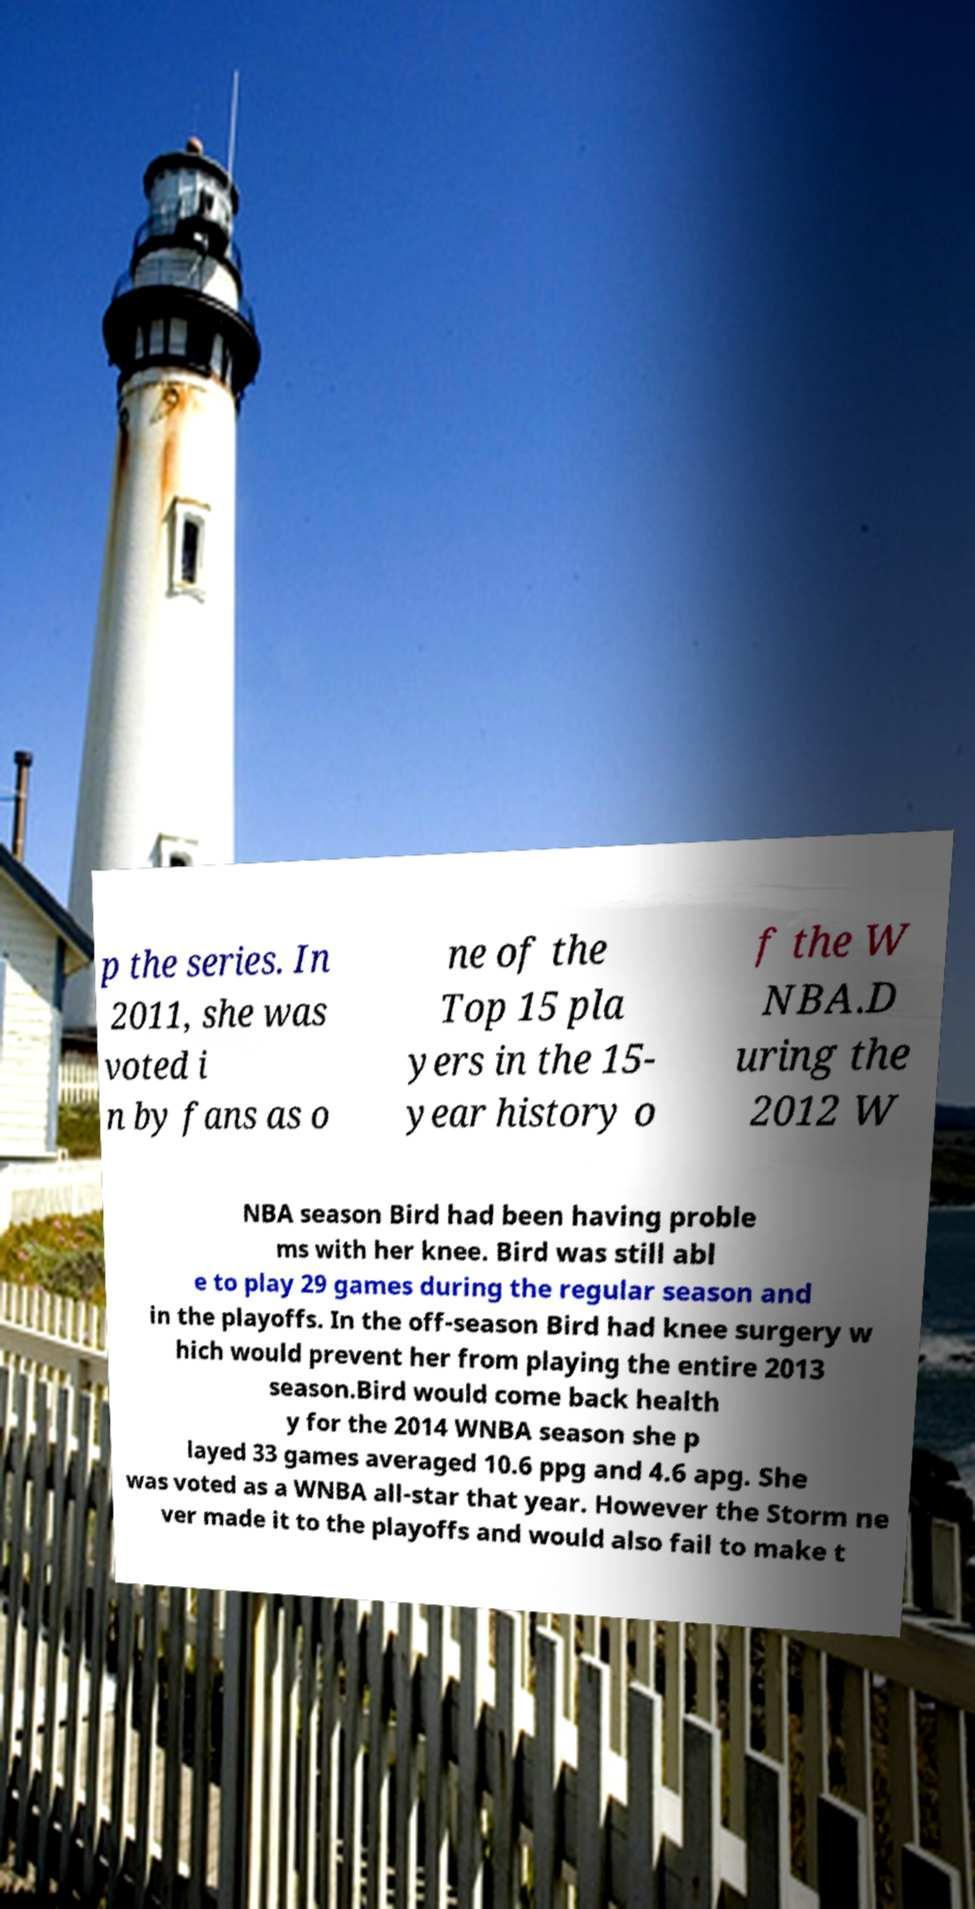There's text embedded in this image that I need extracted. Can you transcribe it verbatim? p the series. In 2011, she was voted i n by fans as o ne of the Top 15 pla yers in the 15- year history o f the W NBA.D uring the 2012 W NBA season Bird had been having proble ms with her knee. Bird was still abl e to play 29 games during the regular season and in the playoffs. In the off-season Bird had knee surgery w hich would prevent her from playing the entire 2013 season.Bird would come back health y for the 2014 WNBA season she p layed 33 games averaged 10.6 ppg and 4.6 apg. She was voted as a WNBA all-star that year. However the Storm ne ver made it to the playoffs and would also fail to make t 